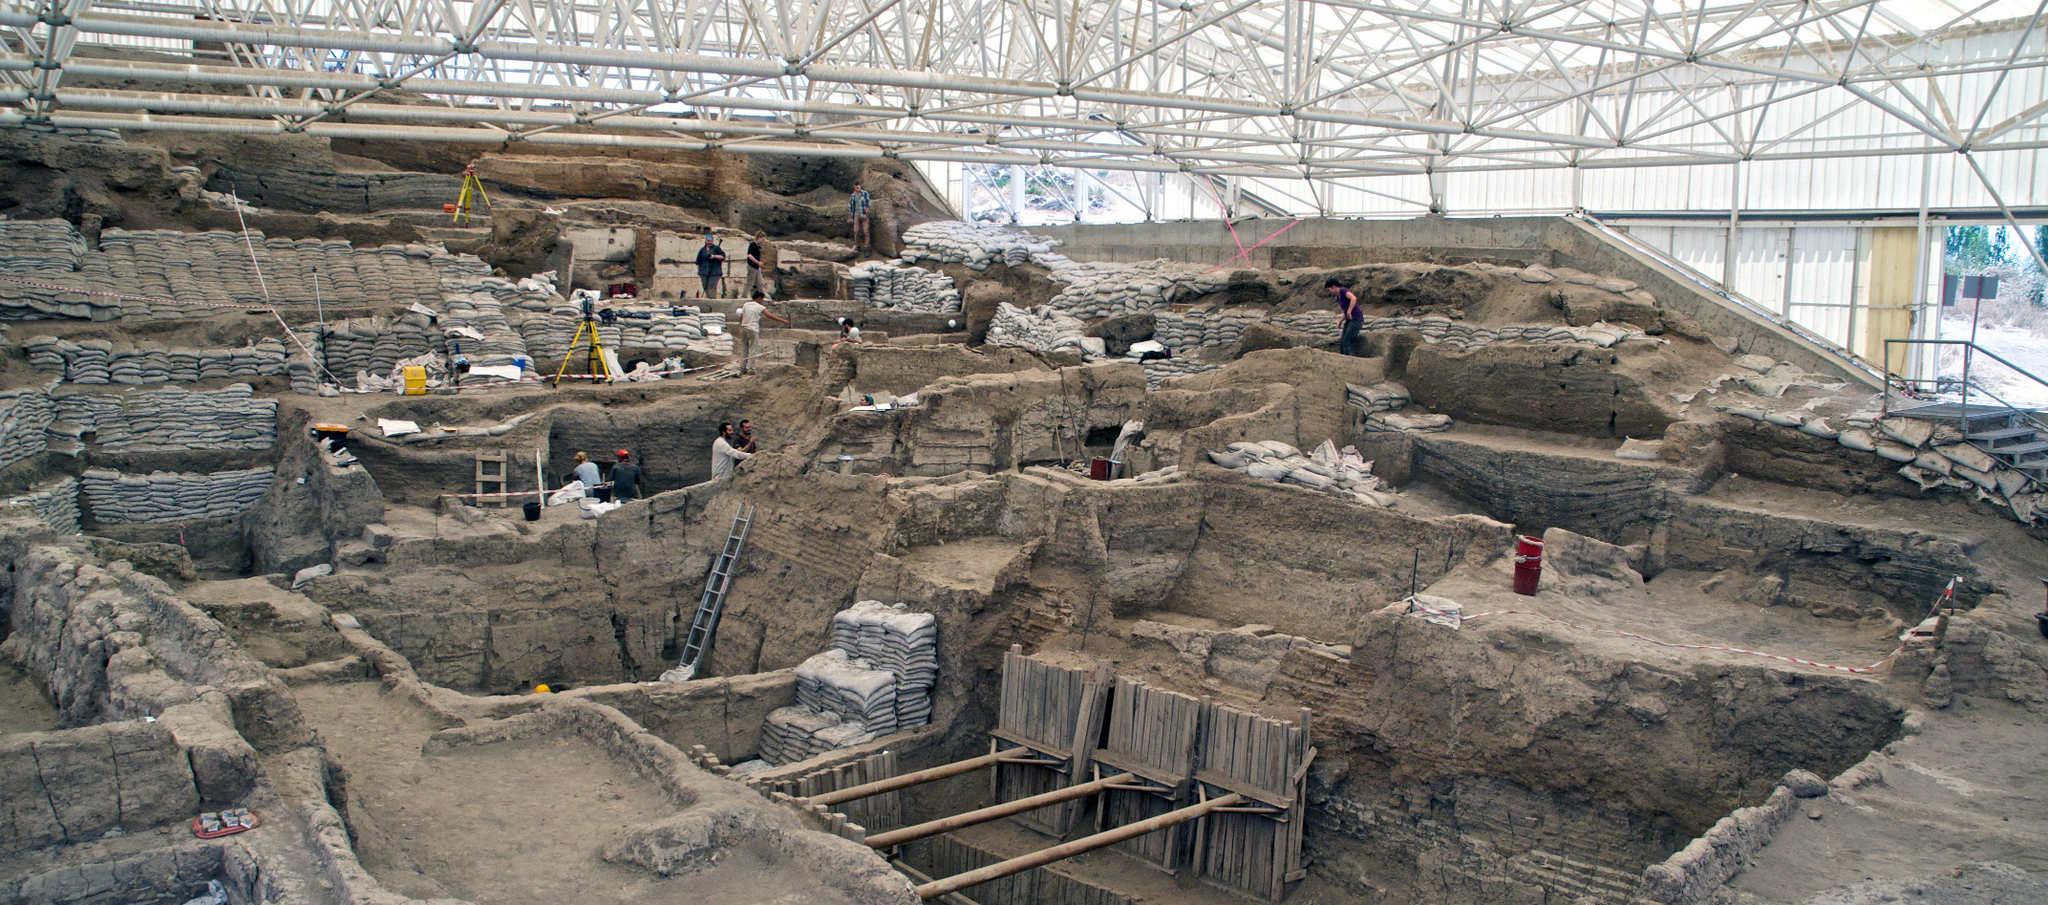Write a detailed description of the given image. The image offers a panoramic view of the Catalhoyuk archaeological site in Turkey, a key locality providing insights into one of the earliest urban agglomerations in human history. It shows a broad, high-angle view of the excavation area, which is covered by a vast, structural white roof to protect both the integrity of the site and the archaeologists at work. Within this view, numerous archaeologists can be seen meticulously examining various layers of civilization, with tools and equipment scattered around them. The site itself reveals a complex arrangement of housing structures and communal facilities, characterized by dense, muddy walls preserved across centuries. This in-depth archaeological effort sheds light on the societal structures and everyday lives of the people who lived around 7500 BC. Banners of bright colors like red and yellow peek through, denoting ongoing measurements and sections of particular interest, injecting life into the otherwise earth-tone dominion. 